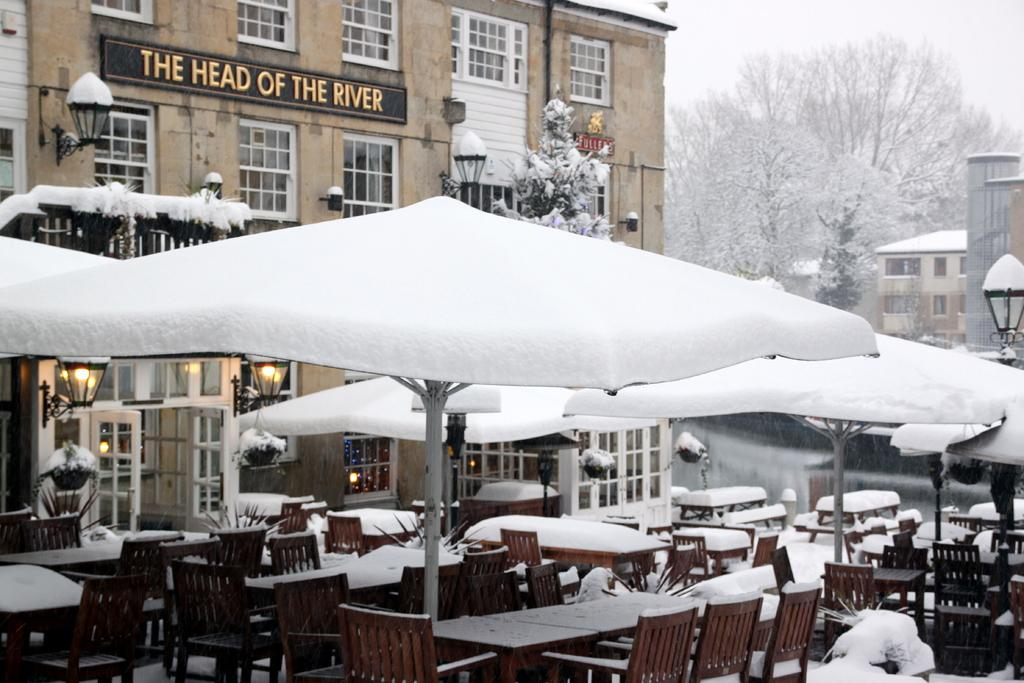What type of furniture can be seen in the image? There are tables and chairs in the image. What can be found above the tables and chairs? There are lights in the image. What are the entrances to the rooms or spaces in the image? There are doors in the image. What items are present for protection from rain or shade? There are umbrellas in the image. What structures can be seen in the distance in the image? There are buildings in the background of the image. What architectural features are visible in the background of the image? There are windows and boards in the background of the image. What type of vegetation is visible in the background of the image? There are trees in the background of the image. What part of the natural environment is visible in the background of the image? The sky is visible in the background of the image. What type of cabbage is being served by the maid in the image? There is no cabbage or maid present in the image. What kind of creature is shown interacting with the umbrellas in the image? There is no creature shown interacting with the umbrellas in the image; only the tables, chairs, lights, doors, umbrellas, buildings, windows, boards, trees, and sky are present. 